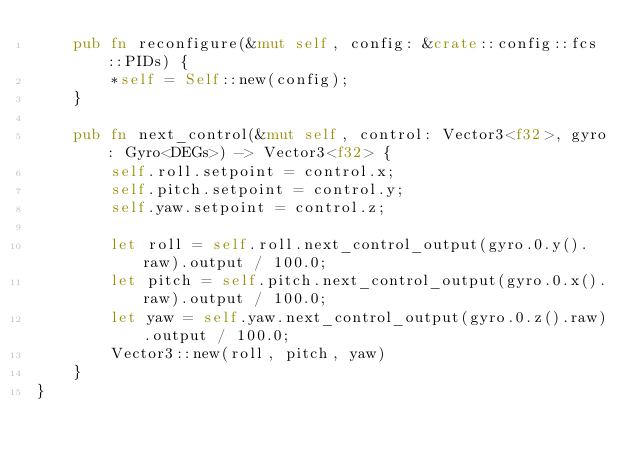<code> <loc_0><loc_0><loc_500><loc_500><_Rust_>    pub fn reconfigure(&mut self, config: &crate::config::fcs::PIDs) {
        *self = Self::new(config);
    }

    pub fn next_control(&mut self, control: Vector3<f32>, gyro: Gyro<DEGs>) -> Vector3<f32> {
        self.roll.setpoint = control.x;
        self.pitch.setpoint = control.y;
        self.yaw.setpoint = control.z;

        let roll = self.roll.next_control_output(gyro.0.y().raw).output / 100.0;
        let pitch = self.pitch.next_control_output(gyro.0.x().raw).output / 100.0;
        let yaw = self.yaw.next_control_output(gyro.0.z().raw).output / 100.0;
        Vector3::new(roll, pitch, yaw)
    }
}
</code> 